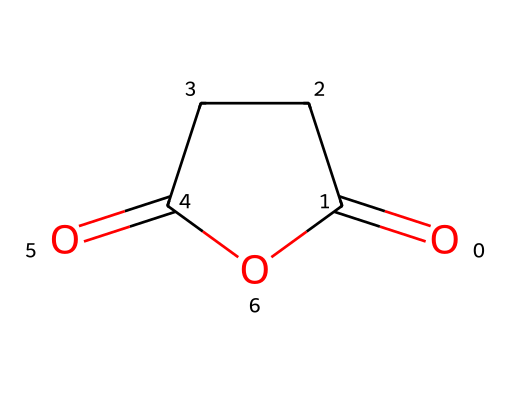What is the molecular formula of succinic anhydride? The molecular formula can be derived from the SMILES representation. It shows that there are four carbon atoms (C), six hydrogen atoms (H), and three oxygen atoms (O). Therefore, the molecular formula is C4H4O3.
Answer: C4H4O3 How many carbon atoms are in the chemical structure? By examining the SMILES representation, there are four carbon atoms present in the structure, as indicated by the symbols 'C'.
Answer: 4 What type of functional groups are present in succinic anhydride? In the structure, we can identify the anhydride functional group characterized by the presence of two carbonyl (C=O) groups and a cyclic structure. This reveals that it is specifically an anhydride derivative.
Answer: anhydride What is the angle between the carbonyl groups in the anhydride? Analyzing the structure, the carbonyl groups are positioned on either side of the cyclic arrangement. The angle will be approximately 120 degrees due to the trigonal planar geometry around the carbonyl carbons.
Answer: 120 degrees What kind of reaction could succinic anhydride undergo? Succinic anhydride can participate in hydrolysis reactions where it reacts with water to form succinic acid. This behavior is typical of acid anhydrides.
Answer: hydrolysis Is succinic anhydride more reactive than typical carboxylic acids? Given that succinic anhydride has a cyclic structure with a highly electrophilic carbonyl, it is indeed more reactive than typical carboxylic acids, which lack the anhydride linkage that enhances reactivity.
Answer: yes 